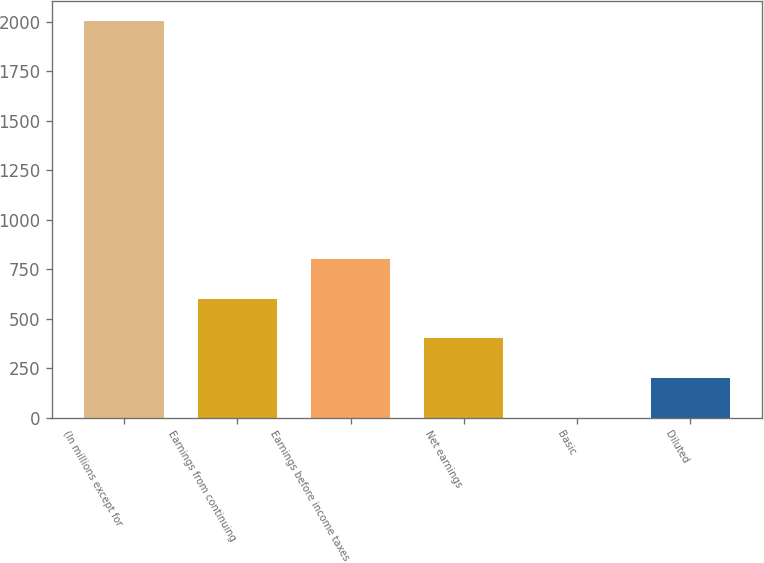<chart> <loc_0><loc_0><loc_500><loc_500><bar_chart><fcel>(In millions except for<fcel>Earnings from continuing<fcel>Earnings before income taxes<fcel>Net earnings<fcel>Basic<fcel>Diluted<nl><fcel>2007<fcel>602.13<fcel>802.82<fcel>401.44<fcel>0.06<fcel>200.75<nl></chart> 